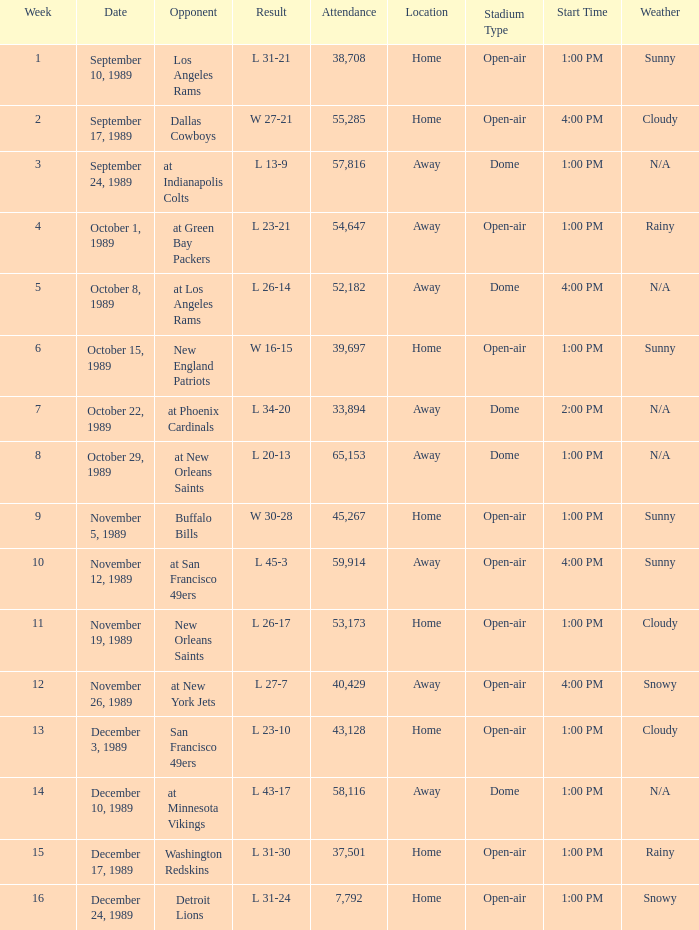The Detroit Lions were played against what week? 16.0. 